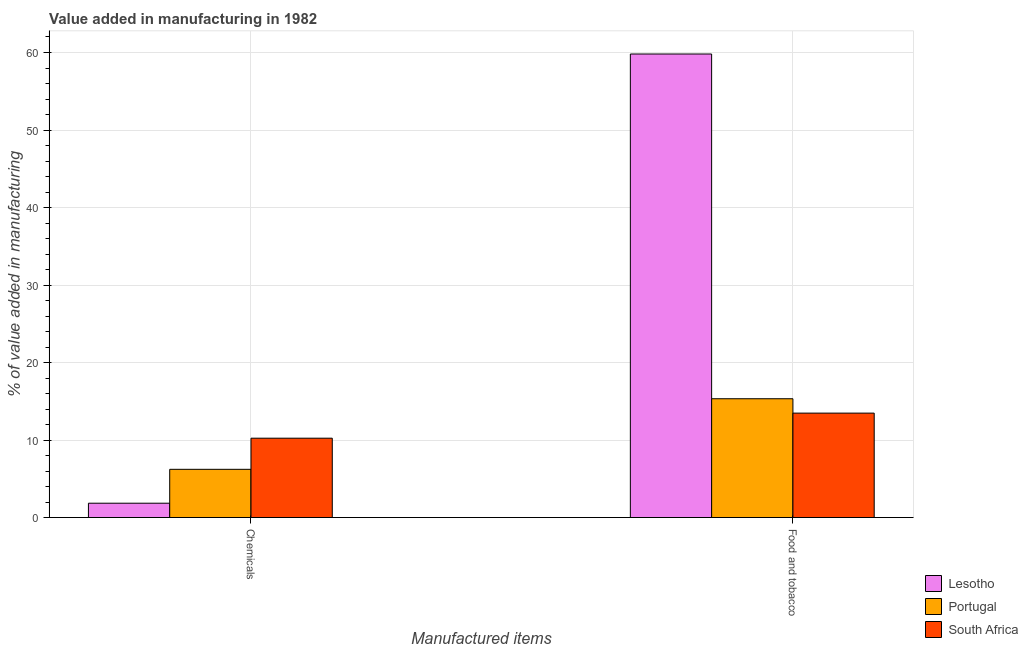How many groups of bars are there?
Give a very brief answer. 2. Are the number of bars on each tick of the X-axis equal?
Your response must be concise. Yes. What is the label of the 2nd group of bars from the left?
Your answer should be compact. Food and tobacco. What is the value added by manufacturing food and tobacco in Lesotho?
Provide a succinct answer. 59.81. Across all countries, what is the maximum value added by  manufacturing chemicals?
Make the answer very short. 10.24. Across all countries, what is the minimum value added by manufacturing food and tobacco?
Offer a very short reply. 13.47. In which country was the value added by  manufacturing chemicals maximum?
Your response must be concise. South Africa. In which country was the value added by manufacturing food and tobacco minimum?
Ensure brevity in your answer.  South Africa. What is the total value added by  manufacturing chemicals in the graph?
Ensure brevity in your answer.  18.32. What is the difference between the value added by  manufacturing chemicals in South Africa and that in Lesotho?
Your answer should be very brief. 8.39. What is the difference between the value added by  manufacturing chemicals in Lesotho and the value added by manufacturing food and tobacco in South Africa?
Offer a terse response. -11.62. What is the average value added by  manufacturing chemicals per country?
Your answer should be compact. 6.11. What is the difference between the value added by  manufacturing chemicals and value added by manufacturing food and tobacco in Portugal?
Your answer should be compact. -9.11. What is the ratio of the value added by manufacturing food and tobacco in Portugal to that in South Africa?
Your response must be concise. 1.14. What does the 1st bar from the left in Food and tobacco represents?
Ensure brevity in your answer.  Lesotho. What does the 3rd bar from the right in Chemicals represents?
Make the answer very short. Lesotho. Does the graph contain any zero values?
Your response must be concise. No. Does the graph contain grids?
Your response must be concise. Yes. What is the title of the graph?
Give a very brief answer. Value added in manufacturing in 1982. Does "Palau" appear as one of the legend labels in the graph?
Make the answer very short. No. What is the label or title of the X-axis?
Ensure brevity in your answer.  Manufactured items. What is the label or title of the Y-axis?
Provide a succinct answer. % of value added in manufacturing. What is the % of value added in manufacturing in Lesotho in Chemicals?
Offer a terse response. 1.85. What is the % of value added in manufacturing of Portugal in Chemicals?
Your answer should be compact. 6.22. What is the % of value added in manufacturing in South Africa in Chemicals?
Provide a succinct answer. 10.24. What is the % of value added in manufacturing of Lesotho in Food and tobacco?
Your answer should be compact. 59.81. What is the % of value added in manufacturing of Portugal in Food and tobacco?
Keep it short and to the point. 15.33. What is the % of value added in manufacturing in South Africa in Food and tobacco?
Offer a terse response. 13.47. Across all Manufactured items, what is the maximum % of value added in manufacturing in Lesotho?
Offer a very short reply. 59.81. Across all Manufactured items, what is the maximum % of value added in manufacturing of Portugal?
Your answer should be compact. 15.33. Across all Manufactured items, what is the maximum % of value added in manufacturing in South Africa?
Your answer should be compact. 13.47. Across all Manufactured items, what is the minimum % of value added in manufacturing of Lesotho?
Your response must be concise. 1.85. Across all Manufactured items, what is the minimum % of value added in manufacturing of Portugal?
Keep it short and to the point. 6.22. Across all Manufactured items, what is the minimum % of value added in manufacturing of South Africa?
Your answer should be compact. 10.24. What is the total % of value added in manufacturing in Lesotho in the graph?
Ensure brevity in your answer.  61.66. What is the total % of value added in manufacturing in Portugal in the graph?
Your answer should be very brief. 21.55. What is the total % of value added in manufacturing in South Africa in the graph?
Give a very brief answer. 23.71. What is the difference between the % of value added in manufacturing of Lesotho in Chemicals and that in Food and tobacco?
Your answer should be compact. -57.95. What is the difference between the % of value added in manufacturing in Portugal in Chemicals and that in Food and tobacco?
Your answer should be very brief. -9.11. What is the difference between the % of value added in manufacturing of South Africa in Chemicals and that in Food and tobacco?
Keep it short and to the point. -3.23. What is the difference between the % of value added in manufacturing of Lesotho in Chemicals and the % of value added in manufacturing of Portugal in Food and tobacco?
Give a very brief answer. -13.48. What is the difference between the % of value added in manufacturing of Lesotho in Chemicals and the % of value added in manufacturing of South Africa in Food and tobacco?
Provide a succinct answer. -11.62. What is the difference between the % of value added in manufacturing of Portugal in Chemicals and the % of value added in manufacturing of South Africa in Food and tobacco?
Offer a very short reply. -7.25. What is the average % of value added in manufacturing of Lesotho per Manufactured items?
Keep it short and to the point. 30.83. What is the average % of value added in manufacturing in Portugal per Manufactured items?
Your answer should be compact. 10.78. What is the average % of value added in manufacturing in South Africa per Manufactured items?
Give a very brief answer. 11.86. What is the difference between the % of value added in manufacturing in Lesotho and % of value added in manufacturing in Portugal in Chemicals?
Your answer should be compact. -4.37. What is the difference between the % of value added in manufacturing in Lesotho and % of value added in manufacturing in South Africa in Chemicals?
Your answer should be very brief. -8.39. What is the difference between the % of value added in manufacturing of Portugal and % of value added in manufacturing of South Africa in Chemicals?
Provide a short and direct response. -4.01. What is the difference between the % of value added in manufacturing in Lesotho and % of value added in manufacturing in Portugal in Food and tobacco?
Ensure brevity in your answer.  44.48. What is the difference between the % of value added in manufacturing in Lesotho and % of value added in manufacturing in South Africa in Food and tobacco?
Offer a terse response. 46.33. What is the difference between the % of value added in manufacturing in Portugal and % of value added in manufacturing in South Africa in Food and tobacco?
Ensure brevity in your answer.  1.86. What is the ratio of the % of value added in manufacturing in Lesotho in Chemicals to that in Food and tobacco?
Offer a terse response. 0.03. What is the ratio of the % of value added in manufacturing in Portugal in Chemicals to that in Food and tobacco?
Provide a short and direct response. 0.41. What is the ratio of the % of value added in manufacturing in South Africa in Chemicals to that in Food and tobacco?
Offer a very short reply. 0.76. What is the difference between the highest and the second highest % of value added in manufacturing of Lesotho?
Provide a succinct answer. 57.95. What is the difference between the highest and the second highest % of value added in manufacturing of Portugal?
Offer a very short reply. 9.11. What is the difference between the highest and the second highest % of value added in manufacturing of South Africa?
Make the answer very short. 3.23. What is the difference between the highest and the lowest % of value added in manufacturing of Lesotho?
Ensure brevity in your answer.  57.95. What is the difference between the highest and the lowest % of value added in manufacturing in Portugal?
Your response must be concise. 9.11. What is the difference between the highest and the lowest % of value added in manufacturing of South Africa?
Provide a short and direct response. 3.23. 